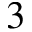Convert formula to latex. <formula><loc_0><loc_0><loc_500><loc_500>3</formula> 